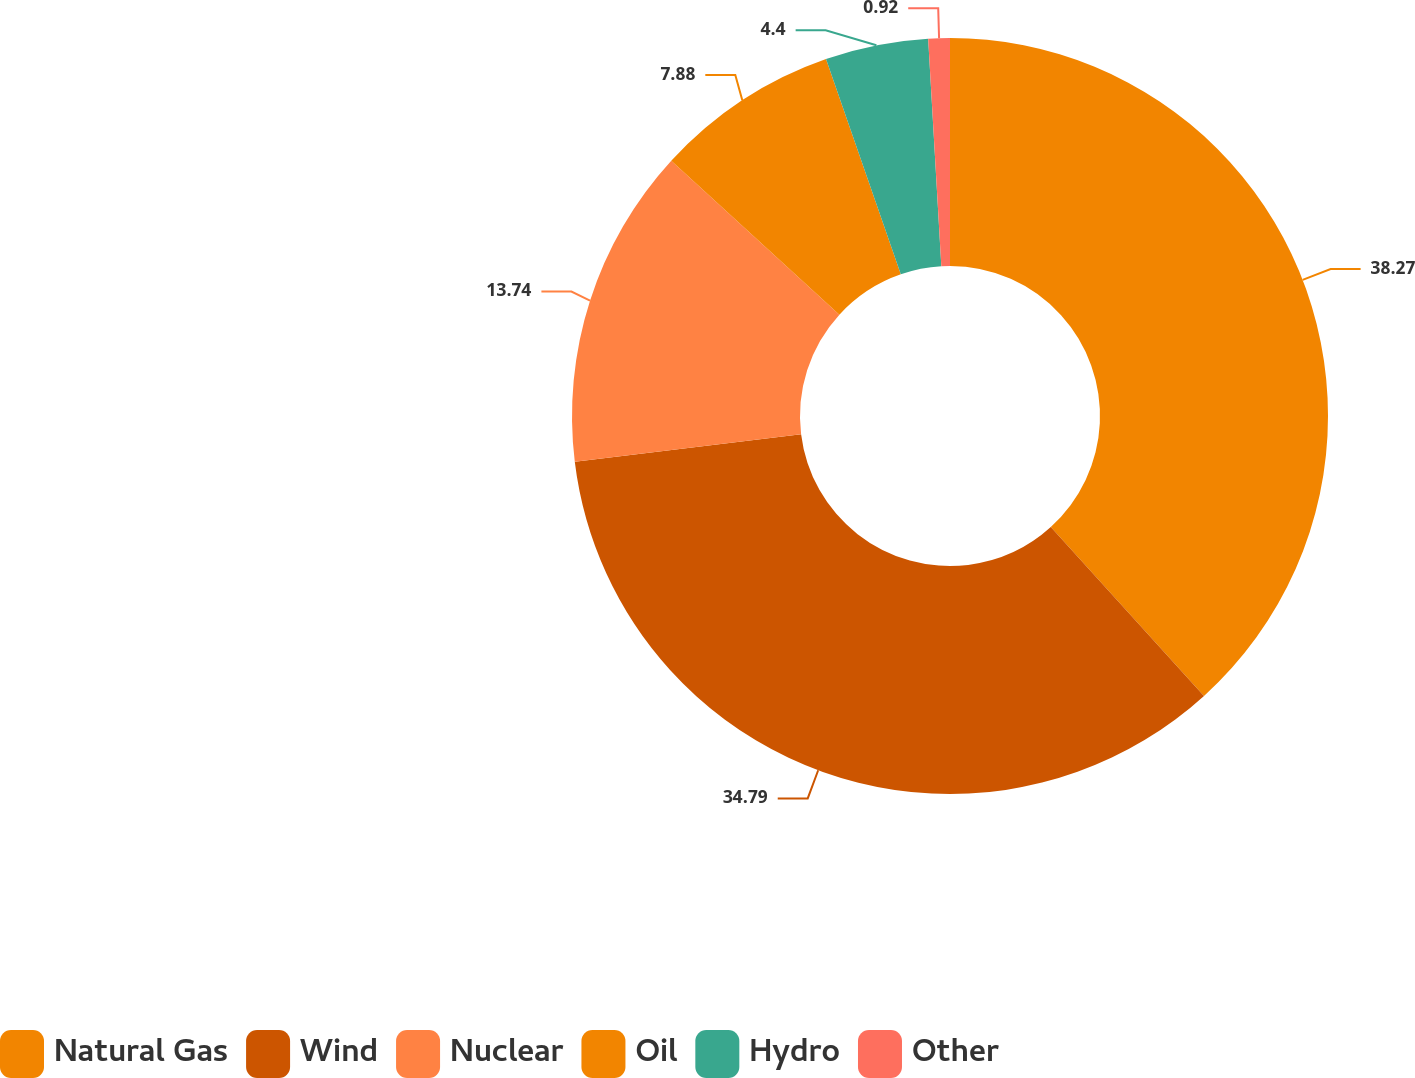Convert chart. <chart><loc_0><loc_0><loc_500><loc_500><pie_chart><fcel>Natural Gas<fcel>Wind<fcel>Nuclear<fcel>Oil<fcel>Hydro<fcel>Other<nl><fcel>38.28%<fcel>34.8%<fcel>13.74%<fcel>7.88%<fcel>4.4%<fcel>0.92%<nl></chart> 